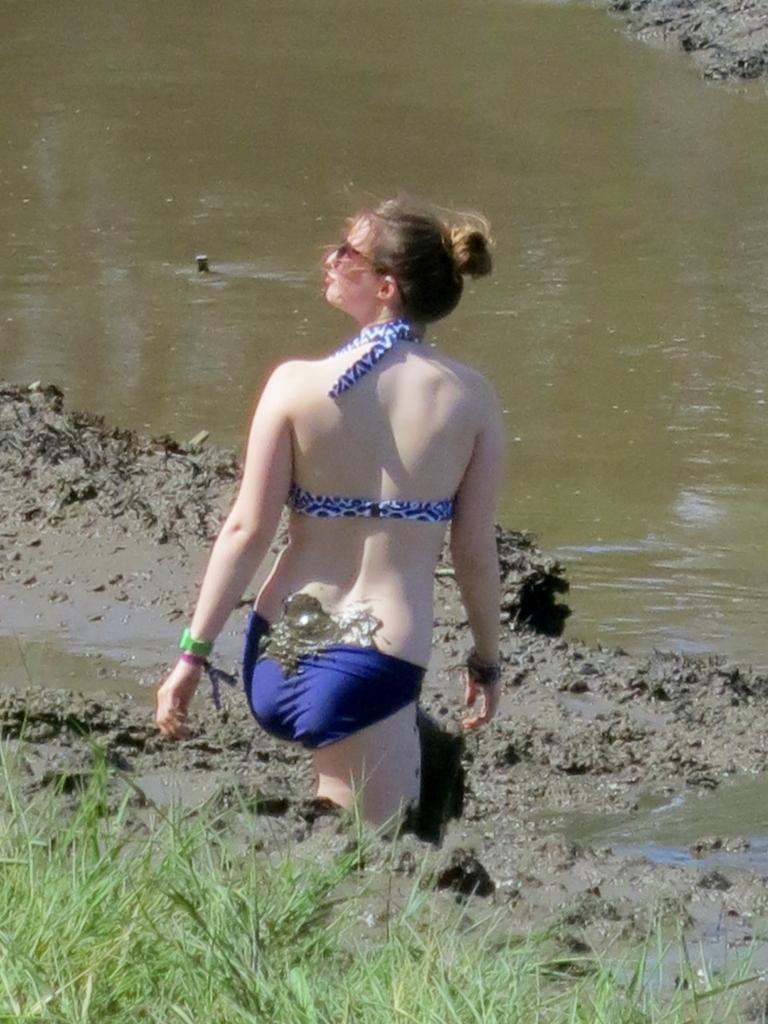Could you give a brief overview of what you see in this image? Here in this picture we can see a woman standing on the ground and in front of her we can see water present all over there and we can see grass also present on the ground over there. 